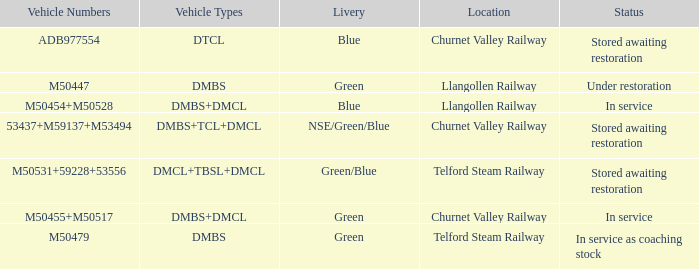What status is the vehicle types of dmbs+tcl+dmcl? Stored awaiting restoration. 